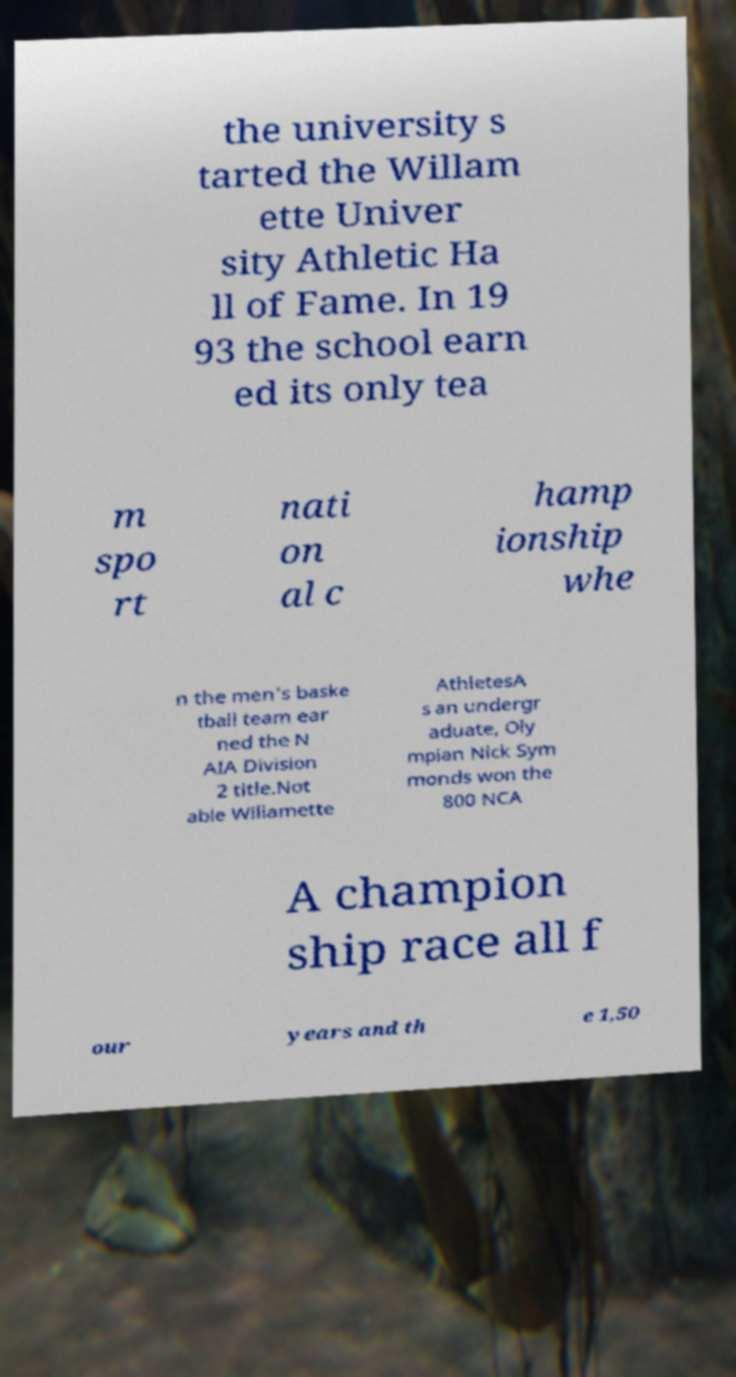There's text embedded in this image that I need extracted. Can you transcribe it verbatim? the university s tarted the Willam ette Univer sity Athletic Ha ll of Fame. In 19 93 the school earn ed its only tea m spo rt nati on al c hamp ionship whe n the men's baske tball team ear ned the N AIA Division 2 title.Not able Willamette AthletesA s an undergr aduate, Oly mpian Nick Sym monds won the 800 NCA A champion ship race all f our years and th e 1,50 